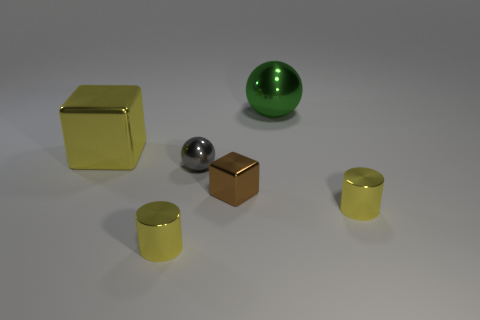What is the color of the metal thing that is in front of the tiny brown shiny object and left of the gray sphere?
Your response must be concise. Yellow. How many objects are either shiny blocks that are in front of the yellow metal cube or blue balls?
Your answer should be compact. 1. What number of other objects are the same color as the big shiny cube?
Make the answer very short. 2. Are there an equal number of small cylinders that are to the left of the yellow shiny cube and tiny cyan matte balls?
Offer a very short reply. Yes. How many shiny balls are in front of the yellow object behind the small shiny cylinder to the right of the tiny shiny sphere?
Give a very brief answer. 1. There is a brown metallic block; is its size the same as the metal cylinder on the left side of the big green ball?
Provide a short and direct response. Yes. What number of yellow shiny cubes are there?
Provide a short and direct response. 1. There is a block that is behind the gray sphere; is it the same size as the metallic cylinder that is on the right side of the green sphere?
Your answer should be very brief. No. What is the color of the other shiny object that is the same shape as the brown object?
Provide a short and direct response. Yellow. Do the gray metal thing and the tiny brown thing have the same shape?
Offer a very short reply. No. 